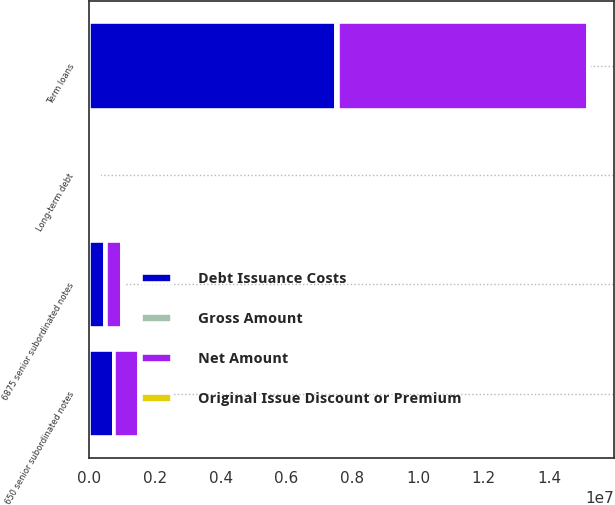<chart> <loc_0><loc_0><loc_500><loc_500><stacked_bar_chart><ecel><fcel>Term loans<fcel>650 senior subordinated notes<fcel>6875 senior subordinated notes<fcel>Long-term debt<nl><fcel>Net Amount<fcel>7.59993e+06<fcel>750000<fcel>500000<fcel>85128.5<nl><fcel>Gross Amount<fcel>69697<fcel>3505<fcel>5616<fcel>100560<nl><fcel>Original Issue Discount or Premium<fcel>21030<fcel>3636<fcel>3605<fcel>20999<nl><fcel>Debt Issuance Costs<fcel>7.5092e+06<fcel>750131<fcel>490779<fcel>85128.5<nl></chart> 